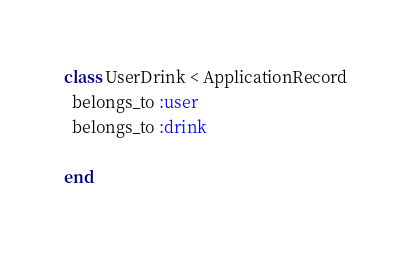<code> <loc_0><loc_0><loc_500><loc_500><_Ruby_>class UserDrink < ApplicationRecord
  belongs_to :user
  belongs_to :drink

end
</code> 